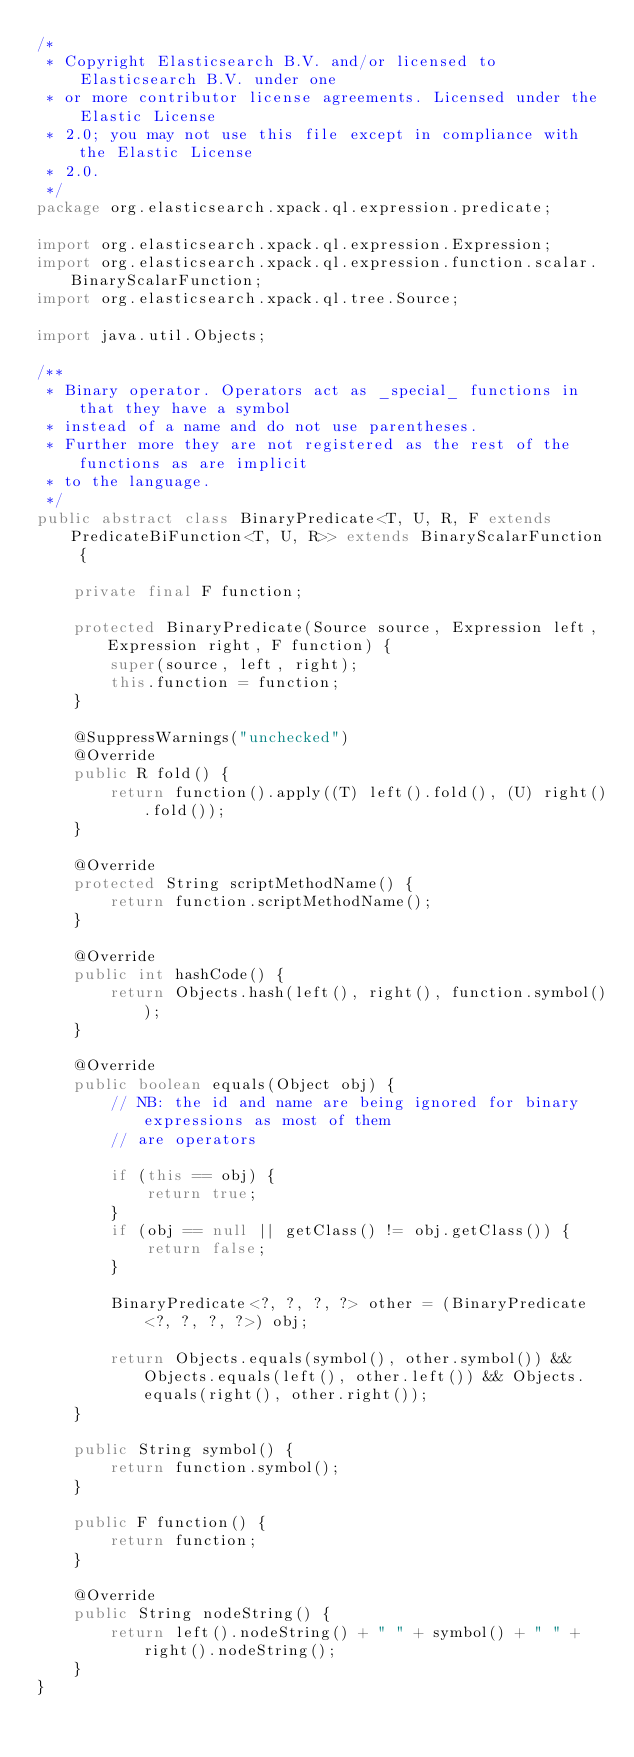<code> <loc_0><loc_0><loc_500><loc_500><_Java_>/*
 * Copyright Elasticsearch B.V. and/or licensed to Elasticsearch B.V. under one
 * or more contributor license agreements. Licensed under the Elastic License
 * 2.0; you may not use this file except in compliance with the Elastic License
 * 2.0.
 */
package org.elasticsearch.xpack.ql.expression.predicate;

import org.elasticsearch.xpack.ql.expression.Expression;
import org.elasticsearch.xpack.ql.expression.function.scalar.BinaryScalarFunction;
import org.elasticsearch.xpack.ql.tree.Source;

import java.util.Objects;

/**
 * Binary operator. Operators act as _special_ functions in that they have a symbol
 * instead of a name and do not use parentheses.
 * Further more they are not registered as the rest of the functions as are implicit
 * to the language.
 */
public abstract class BinaryPredicate<T, U, R, F extends PredicateBiFunction<T, U, R>> extends BinaryScalarFunction {

    private final F function;

    protected BinaryPredicate(Source source, Expression left, Expression right, F function) {
        super(source, left, right);
        this.function = function;
    }

    @SuppressWarnings("unchecked")
    @Override
    public R fold() {
        return function().apply((T) left().fold(), (U) right().fold());
    }

    @Override
    protected String scriptMethodName() {
        return function.scriptMethodName();
    }

    @Override
    public int hashCode() {
        return Objects.hash(left(), right(), function.symbol());
    }

    @Override
    public boolean equals(Object obj) {
        // NB: the id and name are being ignored for binary expressions as most of them
        // are operators

        if (this == obj) {
            return true;
        }
        if (obj == null || getClass() != obj.getClass()) {
            return false;
        }

        BinaryPredicate<?, ?, ?, ?> other = (BinaryPredicate<?, ?, ?, ?>) obj;

        return Objects.equals(symbol(), other.symbol()) && Objects.equals(left(), other.left()) && Objects.equals(right(), other.right());
    }

    public String symbol() {
        return function.symbol();
    }

    public F function() {
        return function;
    }

    @Override
    public String nodeString() {
        return left().nodeString() + " " + symbol() + " " + right().nodeString();
    }
}
</code> 